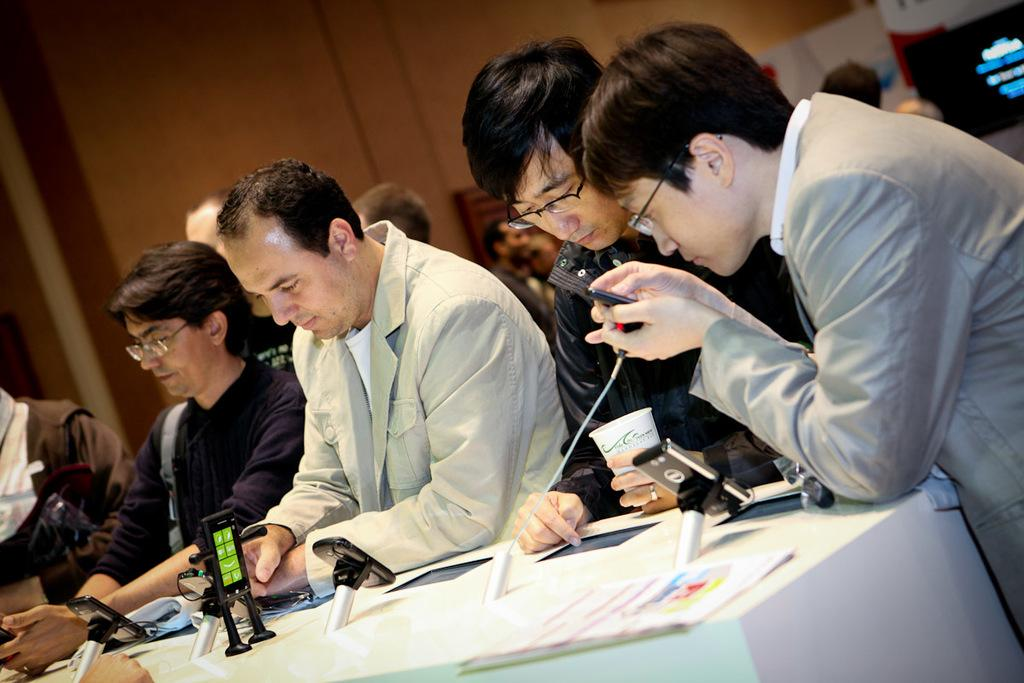What are the people in the image doing? The people in the image are standing in front of a table. What can be seen on the table? There are objects and papers on the table. What type of bean is being used to grip the papers on the table? There is no bean present in the image, and the papers are not being held by any gripping mechanism. 